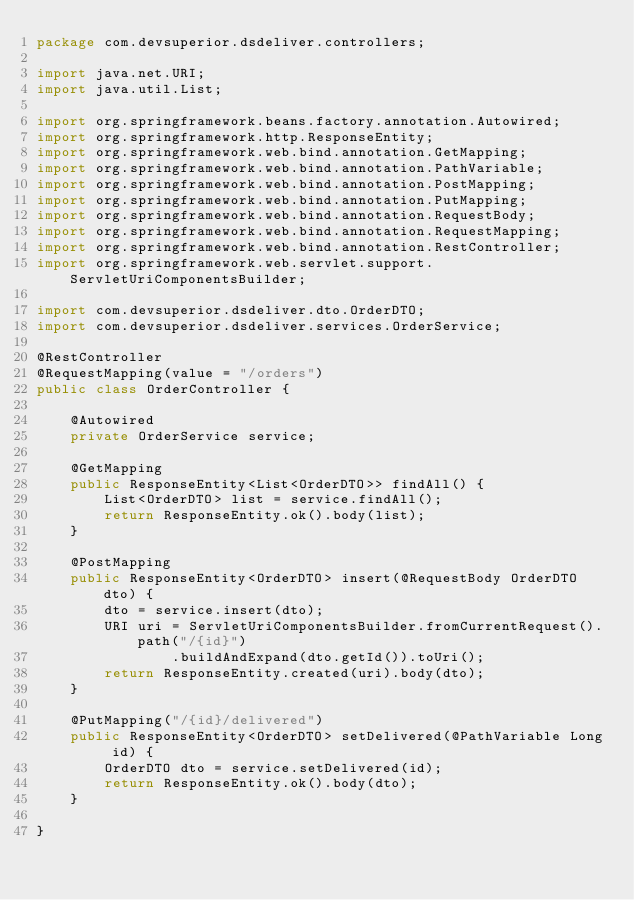<code> <loc_0><loc_0><loc_500><loc_500><_Java_>package com.devsuperior.dsdeliver.controllers;

import java.net.URI;
import java.util.List;

import org.springframework.beans.factory.annotation.Autowired;
import org.springframework.http.ResponseEntity;
import org.springframework.web.bind.annotation.GetMapping;
import org.springframework.web.bind.annotation.PathVariable;
import org.springframework.web.bind.annotation.PostMapping;
import org.springframework.web.bind.annotation.PutMapping;
import org.springframework.web.bind.annotation.RequestBody;
import org.springframework.web.bind.annotation.RequestMapping;
import org.springframework.web.bind.annotation.RestController;
import org.springframework.web.servlet.support.ServletUriComponentsBuilder;

import com.devsuperior.dsdeliver.dto.OrderDTO;
import com.devsuperior.dsdeliver.services.OrderService;

@RestController
@RequestMapping(value = "/orders")
public class OrderController {
	
	@Autowired
	private OrderService service;
	
	@GetMapping
	public ResponseEntity<List<OrderDTO>> findAll() {
		List<OrderDTO> list = service.findAll();
		return ResponseEntity.ok().body(list);
	}
	
	@PostMapping
	public ResponseEntity<OrderDTO> insert(@RequestBody OrderDTO dto) {
		dto = service.insert(dto);
		URI uri = ServletUriComponentsBuilder.fromCurrentRequest().path("/{id}")
				.buildAndExpand(dto.getId()).toUri();
		return ResponseEntity.created(uri).body(dto);
	}
	
	@PutMapping("/{id}/delivered")
	public ResponseEntity<OrderDTO> setDelivered(@PathVariable Long id) {
		OrderDTO dto = service.setDelivered(id);
		return ResponseEntity.ok().body(dto);
	}

}
</code> 